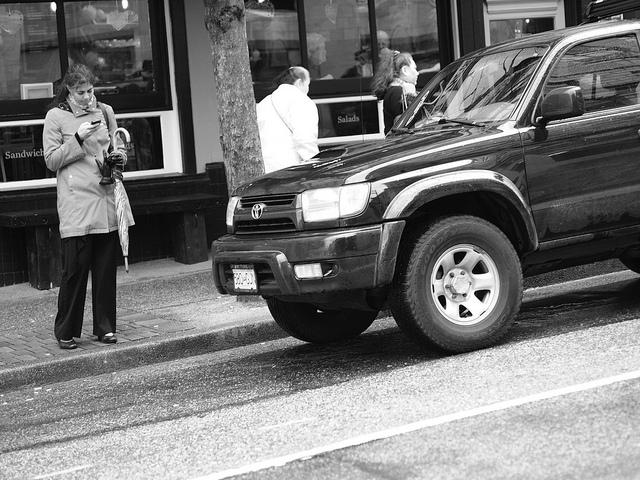Which automotive manufacturer made the jeep?

Choices:
A) kia
B) honda
C) toyota
D) hyundai toyota 